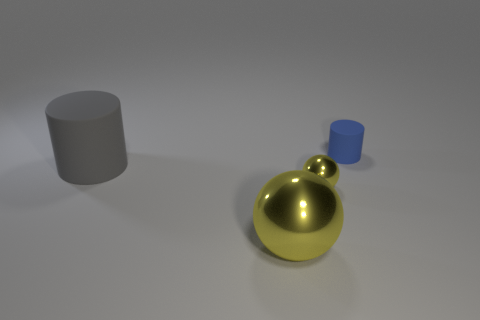Add 2 big rubber cubes. How many objects exist? 6 Add 4 blue cylinders. How many blue cylinders exist? 5 Subtract 0 blue cubes. How many objects are left? 4 Subtract all small green cubes. Subtract all small shiny spheres. How many objects are left? 3 Add 3 small shiny balls. How many small shiny balls are left? 4 